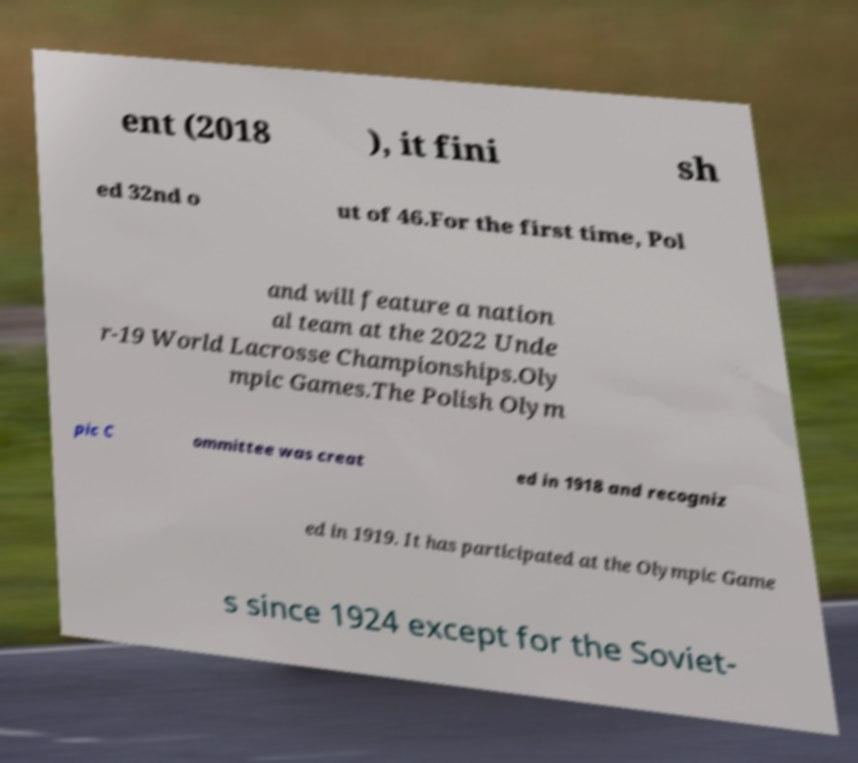Please identify and transcribe the text found in this image. ent (2018 ), it fini sh ed 32nd o ut of 46.For the first time, Pol and will feature a nation al team at the 2022 Unde r-19 World Lacrosse Championships.Oly mpic Games.The Polish Olym pic C ommittee was creat ed in 1918 and recogniz ed in 1919. It has participated at the Olympic Game s since 1924 except for the Soviet- 